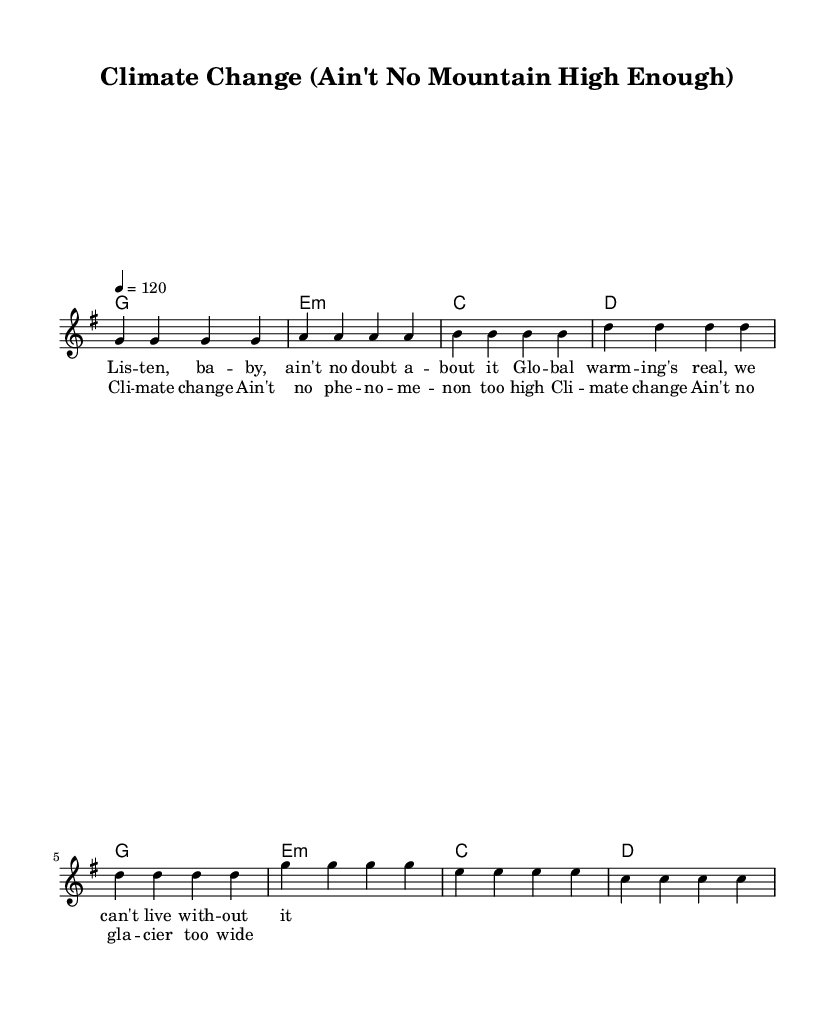What is the key signature of this music? The key signature indicates that the music is in G major, which has one sharp (F#).
Answer: G major What is the time signature of this piece? The time signature is found at the beginning of the music, showing that there are four beats per measure, typically notated as 4/4.
Answer: 4/4 What is the tempo marking for the music? The tempo is specified at the beginning with "4 = 120," which indicates the quarter note is to be played at 120 beats per minute.
Answer: 120 How many lines are present in the staff? In standard notation, there are five lines on a staff, which is a convention in Western music notation.
Answer: Five What is the first chord in the verse? The chord mode shows the first entry is a G major chord, which is indicated by the letter "g" in the first position.
Answer: G Is this music primarily composed of melodies or harmonies? The score shows a clear division between the melodies in the staff and the chords in the chord names, suggesting that melodies take precedence.
Answer: Melodies What theme is explored in the lyrics of this piece? Examining the lyrics shows that they address climate change and its impacts, pivoting the song’s original themes into a scientific context.
Answer: Climate change 